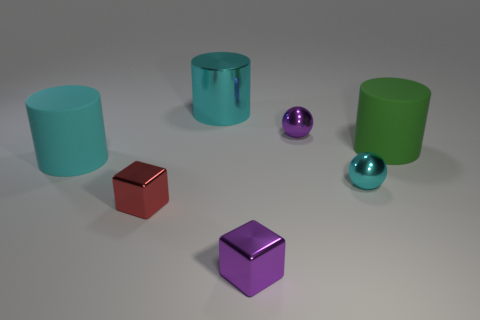Add 1 small yellow cubes. How many objects exist? 8 Subtract all balls. How many objects are left? 5 Add 6 large cyan matte blocks. How many large cyan matte blocks exist? 6 Subtract 0 green balls. How many objects are left? 7 Subtract all big gray spheres. Subtract all purple spheres. How many objects are left? 6 Add 6 small red things. How many small red things are left? 7 